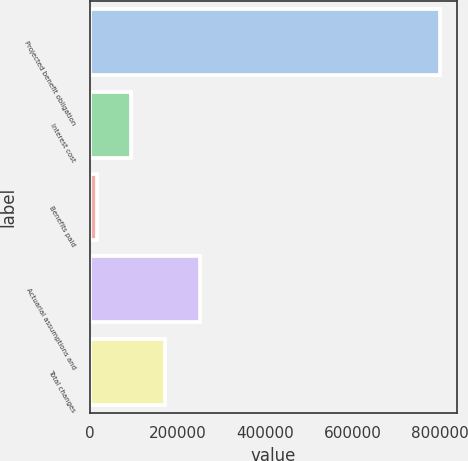Convert chart. <chart><loc_0><loc_0><loc_500><loc_500><bar_chart><fcel>Projected benefit obligation<fcel>Interest cost<fcel>Benefits paid<fcel>Actuarial assumptions and<fcel>Total changes<nl><fcel>799594<fcel>94558.3<fcel>16221<fcel>251233<fcel>172896<nl></chart> 